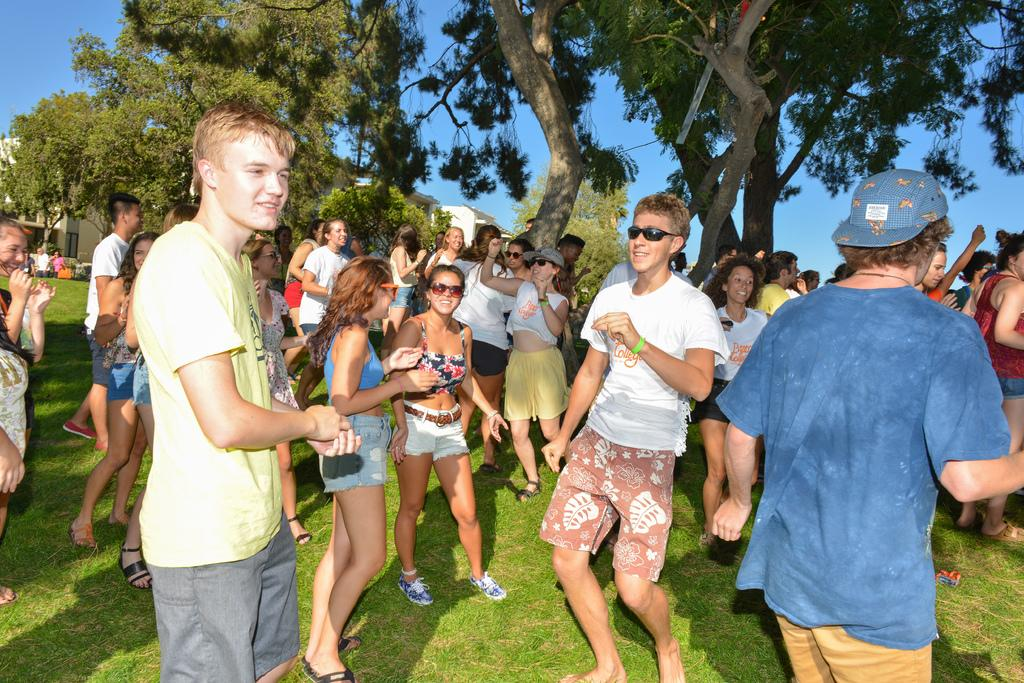Who or what can be seen in the image? There are people in the image. Where are the people located? The people are standing on the grass. What can be seen in the distance behind the people? There are trees and buildings in the background of the image. What is the condition of the sky in the image? The sky is clear in the background of the image. What type of substance is being carried in the pail by the people in the image? There is no pail present in the image, and therefore no substance being carried by the people. 